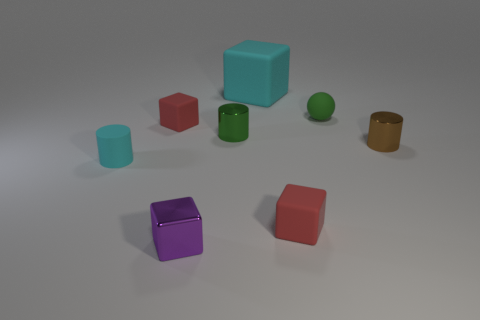Subtract all purple cylinders. How many red cubes are left? 2 Subtract all cyan cubes. How many cubes are left? 3 Subtract all purple blocks. How many blocks are left? 3 Subtract 1 cylinders. How many cylinders are left? 2 Add 2 small cyan rubber things. How many objects exist? 10 Subtract all spheres. How many objects are left? 7 Subtract all green cubes. Subtract all gray balls. How many cubes are left? 4 Subtract all tiny cyan objects. Subtract all green objects. How many objects are left? 5 Add 5 large rubber objects. How many large rubber objects are left? 6 Add 8 large green cubes. How many large green cubes exist? 8 